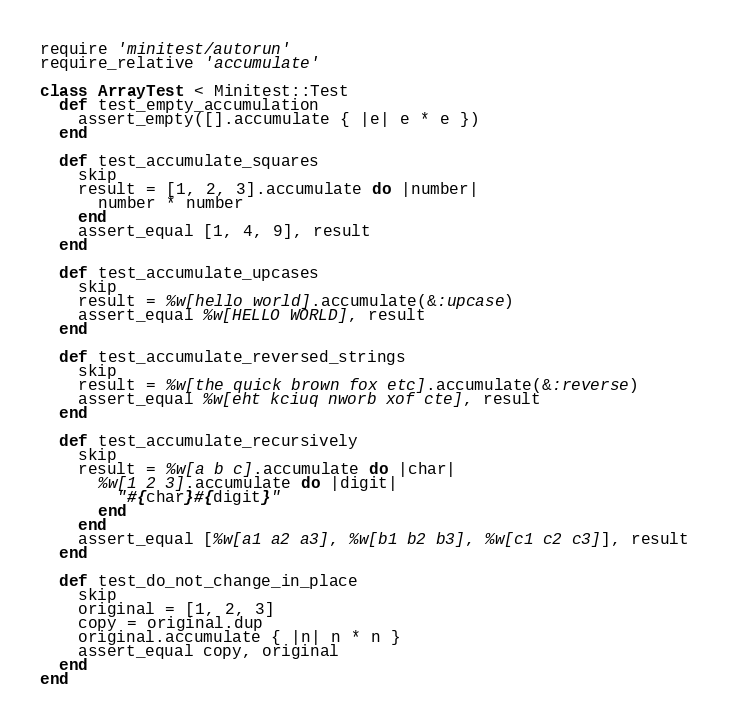Convert code to text. <code><loc_0><loc_0><loc_500><loc_500><_Ruby_>require 'minitest/autorun'
require_relative 'accumulate'

class ArrayTest < Minitest::Test
  def test_empty_accumulation
    assert_empty([].accumulate { |e| e * e })
  end

  def test_accumulate_squares
    skip
    result = [1, 2, 3].accumulate do |number|
      number * number
    end
    assert_equal [1, 4, 9], result
  end

  def test_accumulate_upcases
    skip
    result = %w[hello world].accumulate(&:upcase)
    assert_equal %w[HELLO WORLD], result
  end

  def test_accumulate_reversed_strings
    skip
    result = %w[the quick brown fox etc].accumulate(&:reverse)
    assert_equal %w[eht kciuq nworb xof cte], result
  end

  def test_accumulate_recursively
    skip
    result = %w[a b c].accumulate do |char|
      %w[1 2 3].accumulate do |digit|
        "#{char}#{digit}"
      end
    end
    assert_equal [%w[a1 a2 a3], %w[b1 b2 b3], %w[c1 c2 c3]], result
  end

  def test_do_not_change_in_place
    skip
    original = [1, 2, 3]
    copy = original.dup
    original.accumulate { |n| n * n }
    assert_equal copy, original
  end
end
</code> 